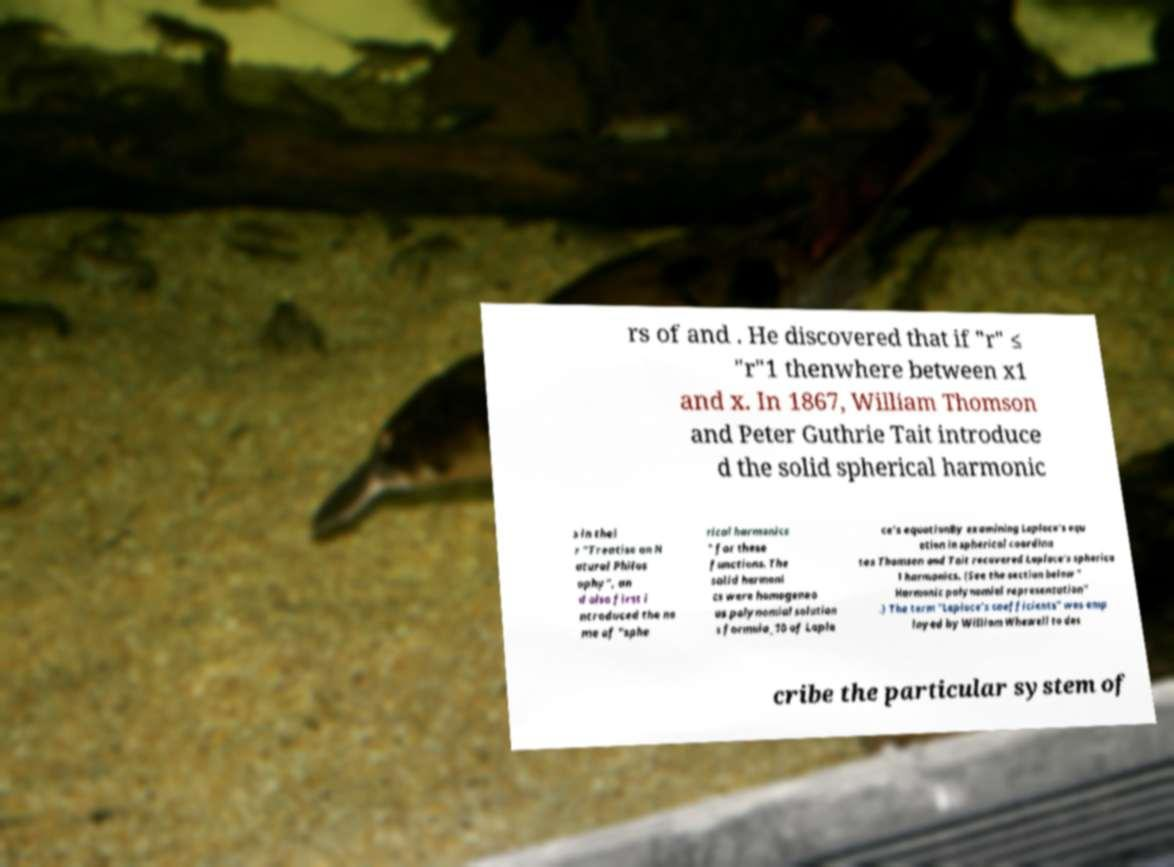Could you extract and type out the text from this image? rs of and . He discovered that if "r" ≤ "r"1 thenwhere between x1 and x. In 1867, William Thomson and Peter Guthrie Tait introduce d the solid spherical harmonic s in thei r "Treatise on N atural Philos ophy", an d also first i ntroduced the na me of "sphe rical harmonics " for these functions. The solid harmoni cs were homogeneo us polynomial solution s formula_10 of Lapla ce's equationBy examining Laplace's equ ation in spherical coordina tes Thomson and Tait recovered Laplace's spherica l harmonics. (See the section below " Harmonic polynomial representation" .) The term "Laplace's coefficients" was emp loyed by William Whewell to des cribe the particular system of 